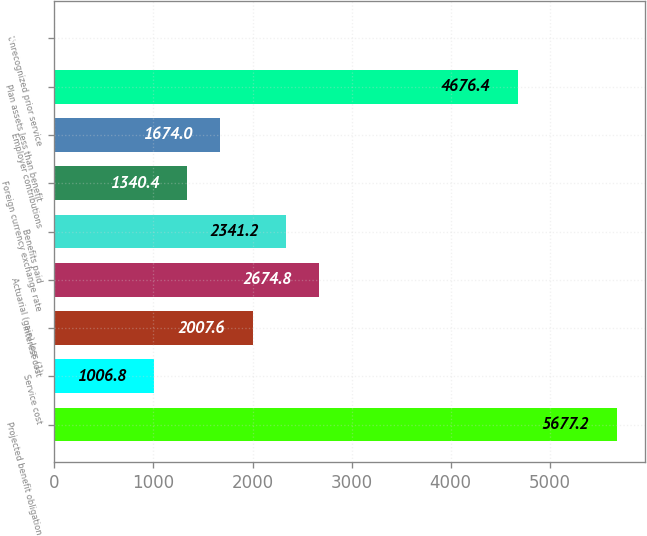Convert chart. <chart><loc_0><loc_0><loc_500><loc_500><bar_chart><fcel>Projected benefit obligation<fcel>Service cost<fcel>Interest cost<fcel>Actuarial (gain) loss (1)<fcel>Benefits paid<fcel>Foreign currency exchange rate<fcel>Employer contributions<fcel>Plan assets less than benefit<fcel>Unrecognized prior service<nl><fcel>5677.2<fcel>1006.8<fcel>2007.6<fcel>2674.8<fcel>2341.2<fcel>1340.4<fcel>1674<fcel>4676.4<fcel>6<nl></chart> 